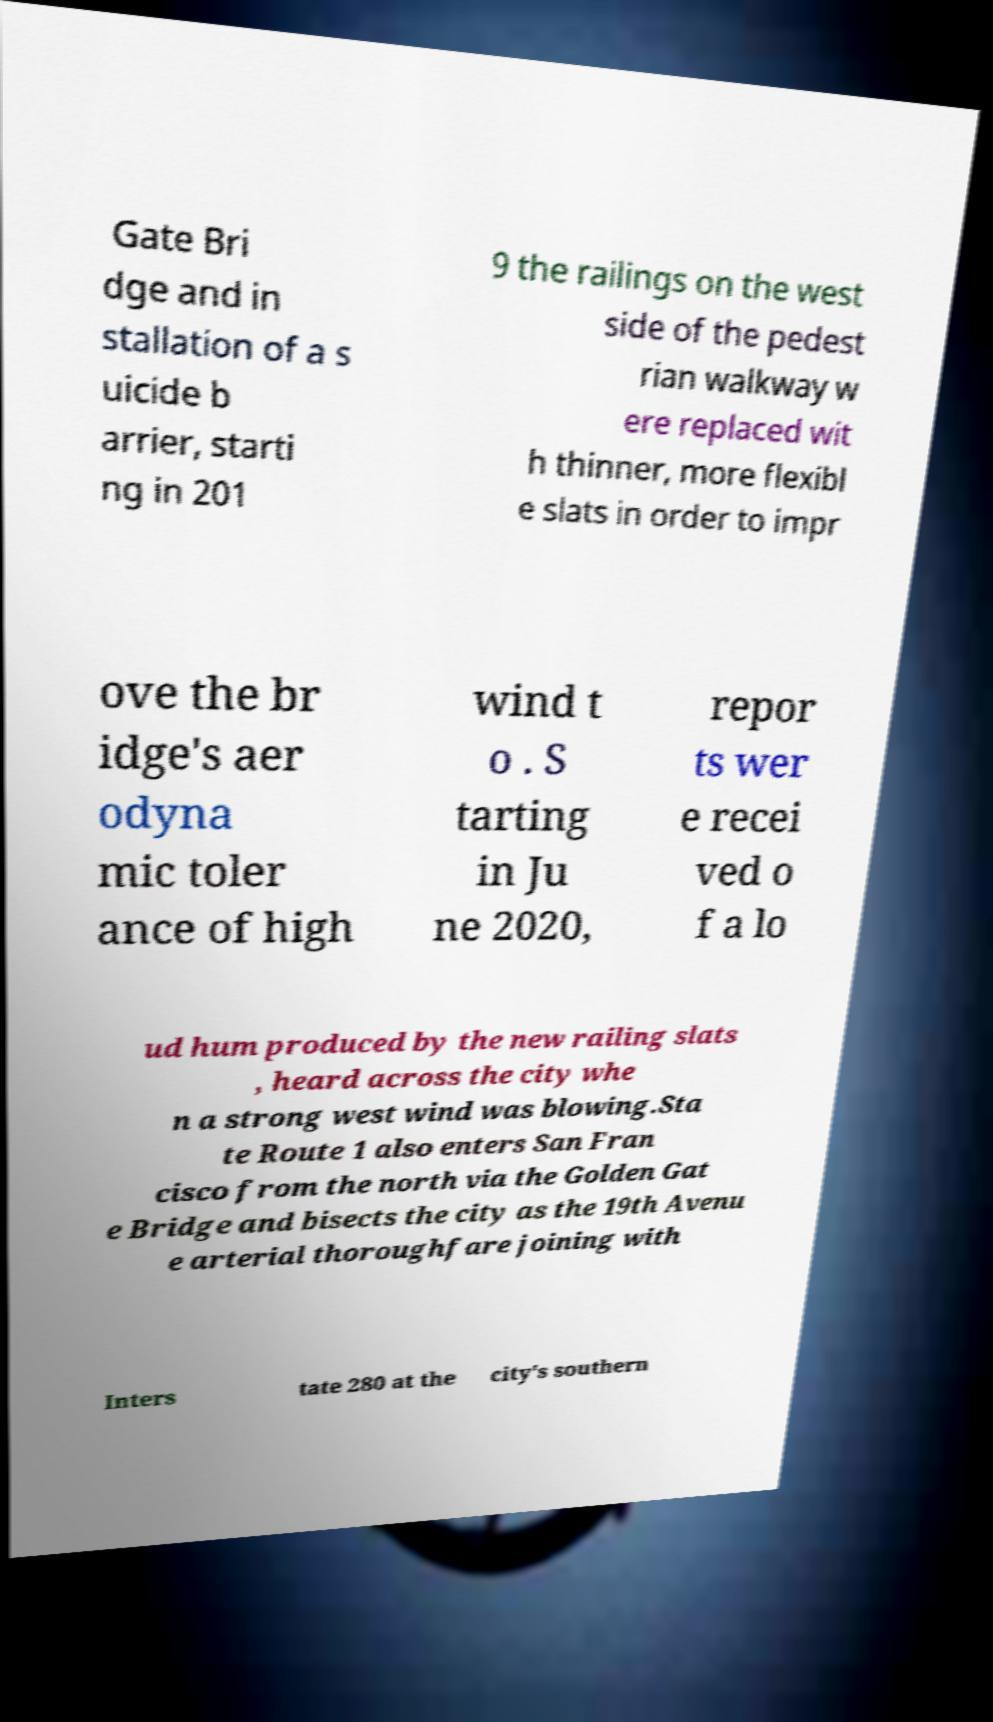Can you accurately transcribe the text from the provided image for me? Gate Bri dge and in stallation of a s uicide b arrier, starti ng in 201 9 the railings on the west side of the pedest rian walkway w ere replaced wit h thinner, more flexibl e slats in order to impr ove the br idge's aer odyna mic toler ance of high wind t o . S tarting in Ju ne 2020, repor ts wer e recei ved o f a lo ud hum produced by the new railing slats , heard across the city whe n a strong west wind was blowing.Sta te Route 1 also enters San Fran cisco from the north via the Golden Gat e Bridge and bisects the city as the 19th Avenu e arterial thoroughfare joining with Inters tate 280 at the city's southern 